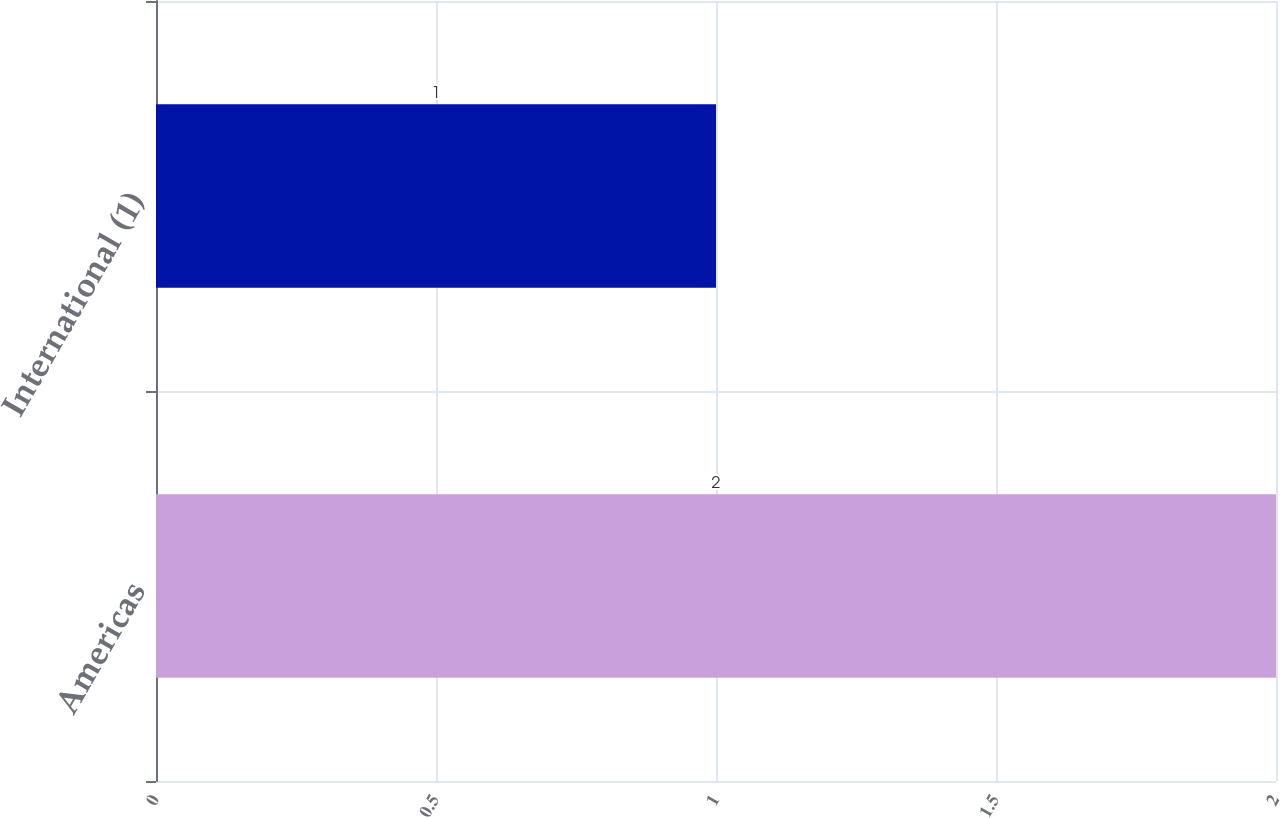Convert chart. <chart><loc_0><loc_0><loc_500><loc_500><bar_chart><fcel>Americas<fcel>International (1)<nl><fcel>2<fcel>1<nl></chart> 